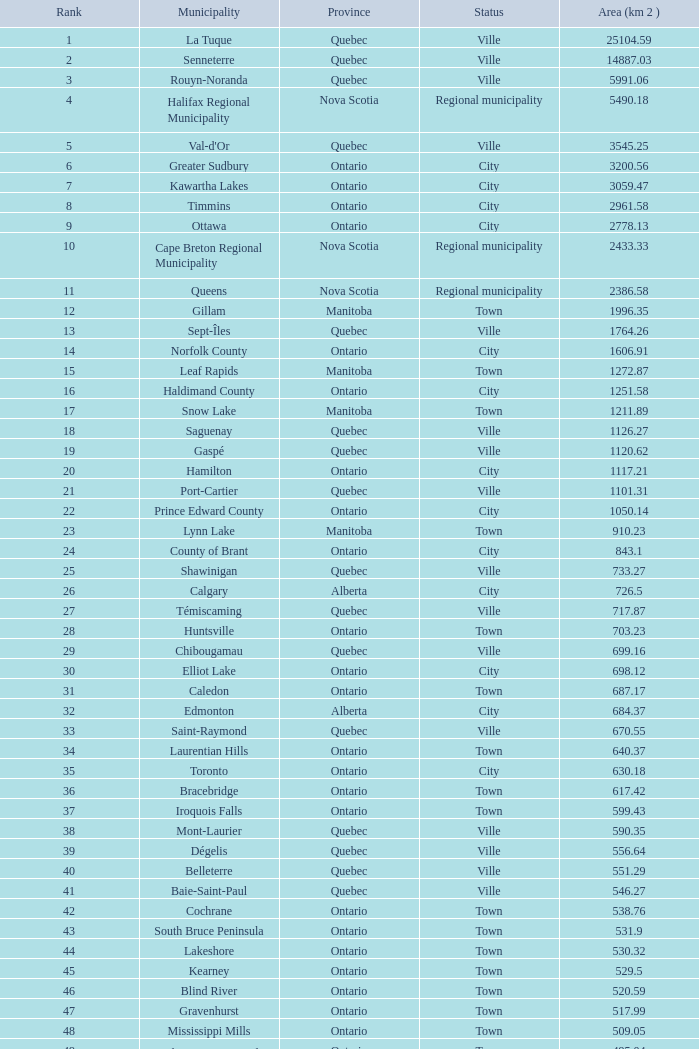What Municipality has a Rank of 44? Lakeshore. 